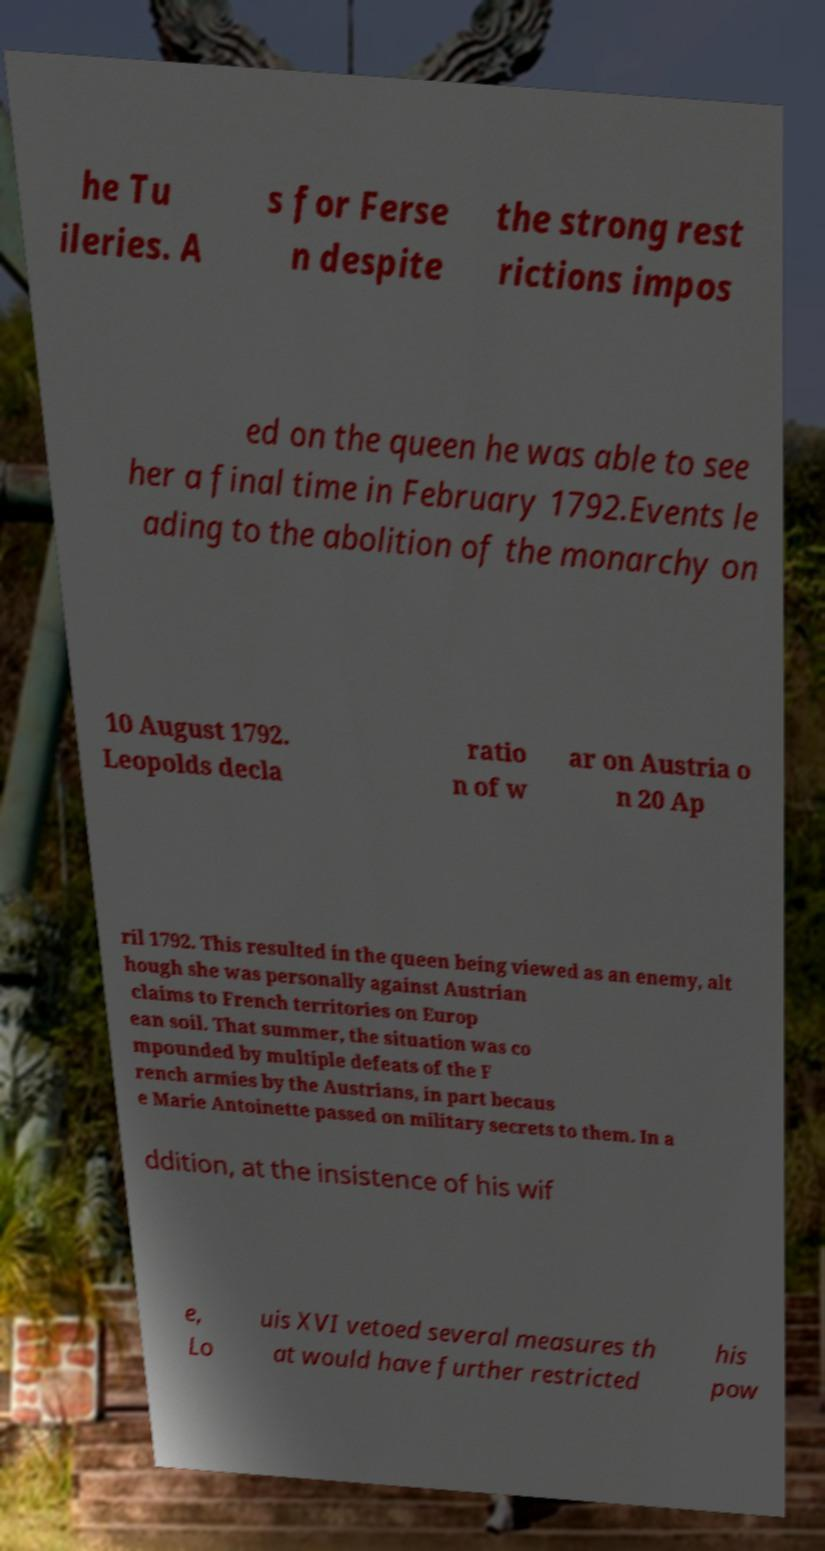Please identify and transcribe the text found in this image. he Tu ileries. A s for Ferse n despite the strong rest rictions impos ed on the queen he was able to see her a final time in February 1792.Events le ading to the abolition of the monarchy on 10 August 1792. Leopolds decla ratio n of w ar on Austria o n 20 Ap ril 1792. This resulted in the queen being viewed as an enemy, alt hough she was personally against Austrian claims to French territories on Europ ean soil. That summer, the situation was co mpounded by multiple defeats of the F rench armies by the Austrians, in part becaus e Marie Antoinette passed on military secrets to them. In a ddition, at the insistence of his wif e, Lo uis XVI vetoed several measures th at would have further restricted his pow 